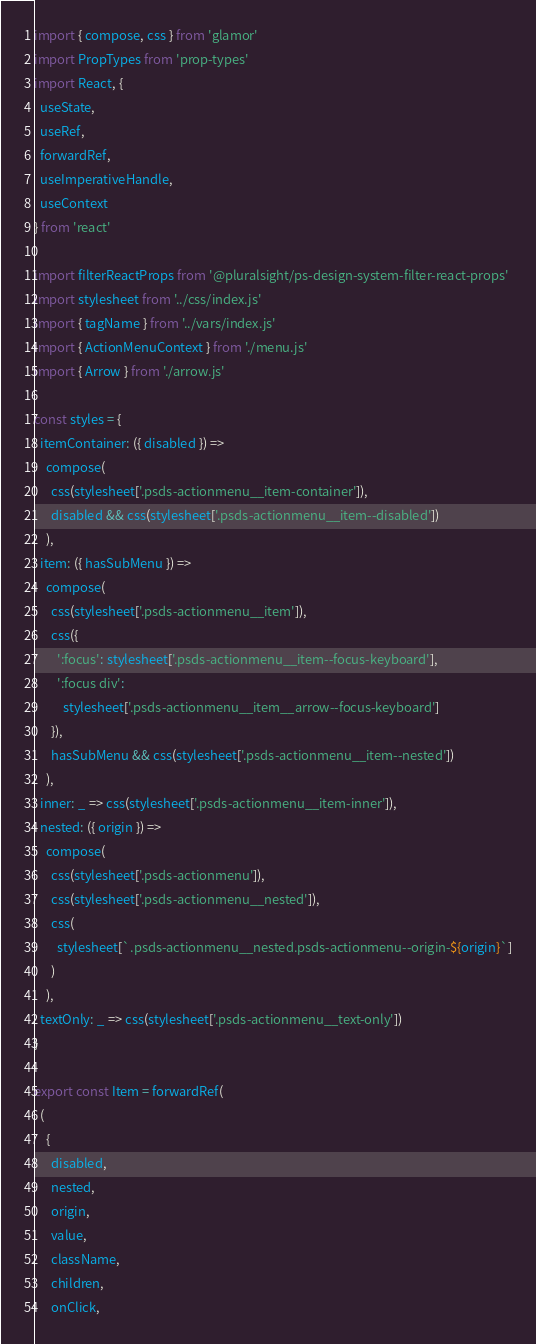Convert code to text. <code><loc_0><loc_0><loc_500><loc_500><_JavaScript_>import { compose, css } from 'glamor'
import PropTypes from 'prop-types'
import React, {
  useState,
  useRef,
  forwardRef,
  useImperativeHandle,
  useContext
} from 'react'

import filterReactProps from '@pluralsight/ps-design-system-filter-react-props'
import stylesheet from '../css/index.js'
import { tagName } from '../vars/index.js'
import { ActionMenuContext } from './menu.js'
import { Arrow } from './arrow.js'

const styles = {
  itemContainer: ({ disabled }) =>
    compose(
      css(stylesheet['.psds-actionmenu__item-container']),
      disabled && css(stylesheet['.psds-actionmenu__item--disabled'])
    ),
  item: ({ hasSubMenu }) =>
    compose(
      css(stylesheet['.psds-actionmenu__item']),
      css({
        ':focus': stylesheet['.psds-actionmenu__item--focus-keyboard'],
        ':focus div':
          stylesheet['.psds-actionmenu__item__arrow--focus-keyboard']
      }),
      hasSubMenu && css(stylesheet['.psds-actionmenu__item--nested'])
    ),
  inner: _ => css(stylesheet['.psds-actionmenu__item-inner']),
  nested: ({ origin }) =>
    compose(
      css(stylesheet['.psds-actionmenu']),
      css(stylesheet['.psds-actionmenu__nested']),
      css(
        stylesheet[`.psds-actionmenu__nested.psds-actionmenu--origin-${origin}`]
      )
    ),
  textOnly: _ => css(stylesheet['.psds-actionmenu__text-only'])
}

export const Item = forwardRef(
  (
    {
      disabled,
      nested,
      origin,
      value,
      className,
      children,
      onClick,</code> 